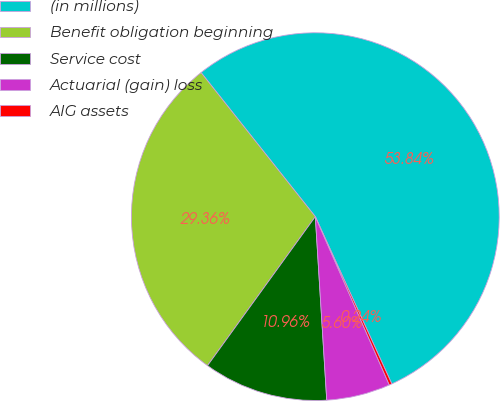<chart> <loc_0><loc_0><loc_500><loc_500><pie_chart><fcel>(in millions)<fcel>Benefit obligation beginning<fcel>Service cost<fcel>Actuarial (gain) loss<fcel>AIG assets<nl><fcel>53.84%<fcel>29.36%<fcel>10.96%<fcel>5.6%<fcel>0.24%<nl></chart> 